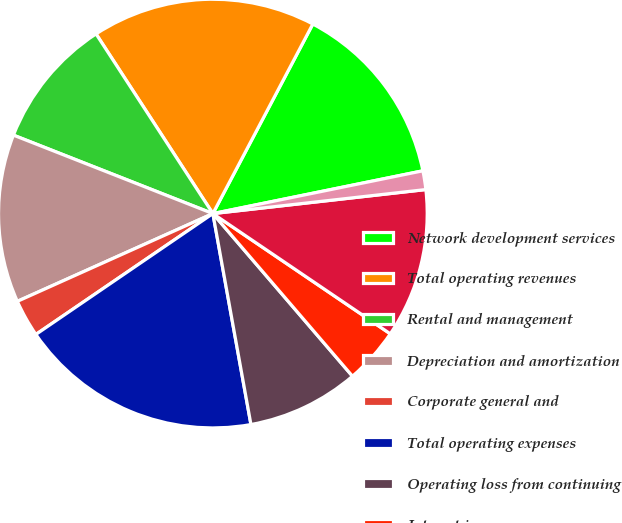Convert chart to OTSL. <chart><loc_0><loc_0><loc_500><loc_500><pie_chart><fcel>Network development services<fcel>Total operating revenues<fcel>Rental and management<fcel>Depreciation and amortization<fcel>Corporate general and<fcel>Total operating expenses<fcel>Operating loss from continuing<fcel>Interest income<fcel>Interest expense<fcel>Minority interest in net<nl><fcel>14.08%<fcel>16.9%<fcel>9.86%<fcel>12.68%<fcel>2.82%<fcel>18.31%<fcel>8.45%<fcel>4.23%<fcel>11.27%<fcel>1.41%<nl></chart> 